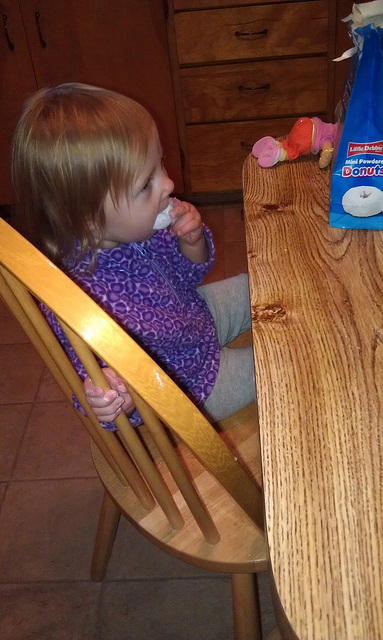Identify and read out the text in this image. Donut 